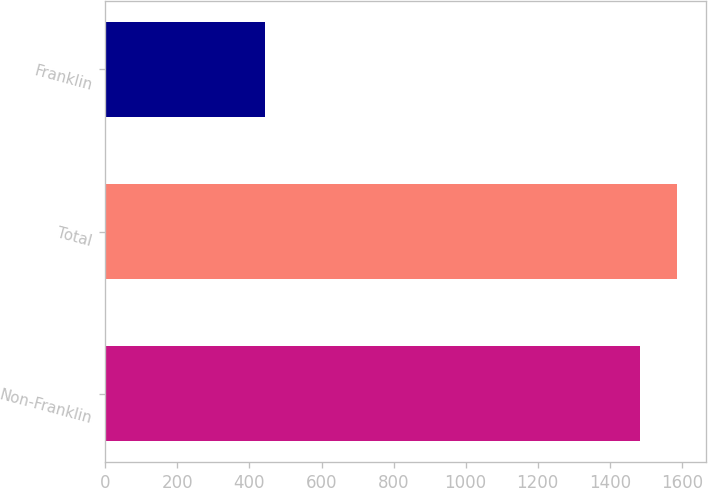<chart> <loc_0><loc_0><loc_500><loc_500><bar_chart><fcel>Non-Franklin<fcel>Total<fcel>Franklin<nl><fcel>1482.5<fcel>1586.36<fcel>443.9<nl></chart> 